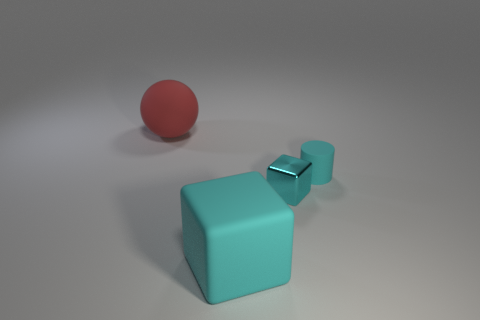Add 4 metal cubes. How many objects exist? 8 Subtract all spheres. How many objects are left? 3 Subtract all cyan blocks. How many blue balls are left? 0 Subtract all cubes. Subtract all small yellow things. How many objects are left? 2 Add 3 small blocks. How many small blocks are left? 4 Add 3 rubber objects. How many rubber objects exist? 6 Subtract 1 cyan cylinders. How many objects are left? 3 Subtract 1 cubes. How many cubes are left? 1 Subtract all purple spheres. Subtract all brown blocks. How many spheres are left? 1 